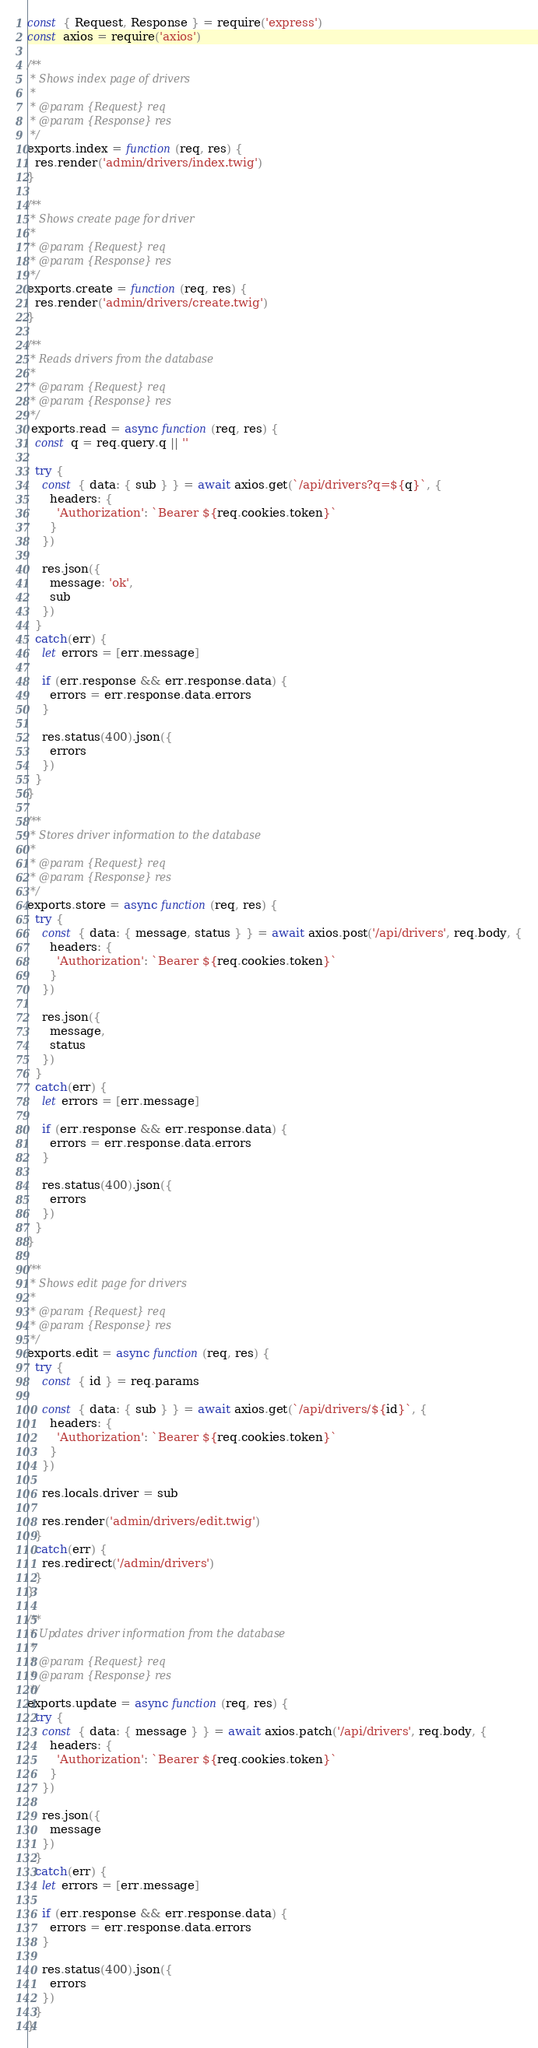Convert code to text. <code><loc_0><loc_0><loc_500><loc_500><_JavaScript_>const { Request, Response } = require('express')
const axios = require('axios')

/**
 * Shows index page of drivers
 * 
 * @param {Request} req 
 * @param {Response} res 
 */
exports.index = function(req, res) {
  res.render('admin/drivers/index.twig')
}

/**
 * Shows create page for driver
 * 
 * @param {Request} req 
 * @param {Response} res 
 */
exports.create = function(req, res) {
  res.render('admin/drivers/create.twig')
}

/**
 * Reads drivers from the database
 * 
 * @param {Request} req 
 * @param {Response} res 
 */
 exports.read = async function(req, res) {
  const q = req.query.q || ''

  try {
    const { data: { sub } } = await axios.get(`/api/drivers?q=${q}`, {
      headers: {
        'Authorization': `Bearer ${req.cookies.token}`
      }
    })

    res.json({
      message: 'ok',
      sub
    })
  }
  catch(err) {
    let errors = [err.message]

    if (err.response && err.response.data) {
      errors = err.response.data.errors
    }

    res.status(400).json({
      errors
    })
  }
}

/**
 * Stores driver information to the database
 * 
 * @param {Request} req 
 * @param {Response} res 
 */
exports.store = async function(req, res) {
  try {
    const { data: { message, status } } = await axios.post('/api/drivers', req.body, {
      headers: {
        'Authorization': `Bearer ${req.cookies.token}`
      }
    })

    res.json({
      message,
      status
    })
  }
  catch(err) {
    let errors = [err.message]

    if (err.response && err.response.data) {
      errors = err.response.data.errors
    }

    res.status(400).json({
      errors
    })
  }
}

/**
 * Shows edit page for drivers
 * 
 * @param {Request} req 
 * @param {Response} res 
 */
exports.edit = async function(req, res) {
  try {
    const { id } = req.params

    const { data: { sub } } = await axios.get(`/api/drivers/${id}`, {
      headers: {
        'Authorization': `Bearer ${req.cookies.token}`
      }
    })

    res.locals.driver = sub

    res.render('admin/drivers/edit.twig')
  }
  catch(err) {
    res.redirect('/admin/drivers')
  }
}

/**
 * Updates driver information from the database 
 * 
 * @param {Request} req 
 * @param {Response} res 
 */
exports.update = async function(req, res) {
  try {
    const { data: { message } } = await axios.patch('/api/drivers', req.body, {
      headers: {
        'Authorization': `Bearer ${req.cookies.token}`
      }
    })

    res.json({
      message
    })
  }
  catch(err) {
    let errors = [err.message]

    if (err.response && err.response.data) {
      errors = err.response.data.errors
    }

    res.status(400).json({
      errors
    })
  }
}</code> 